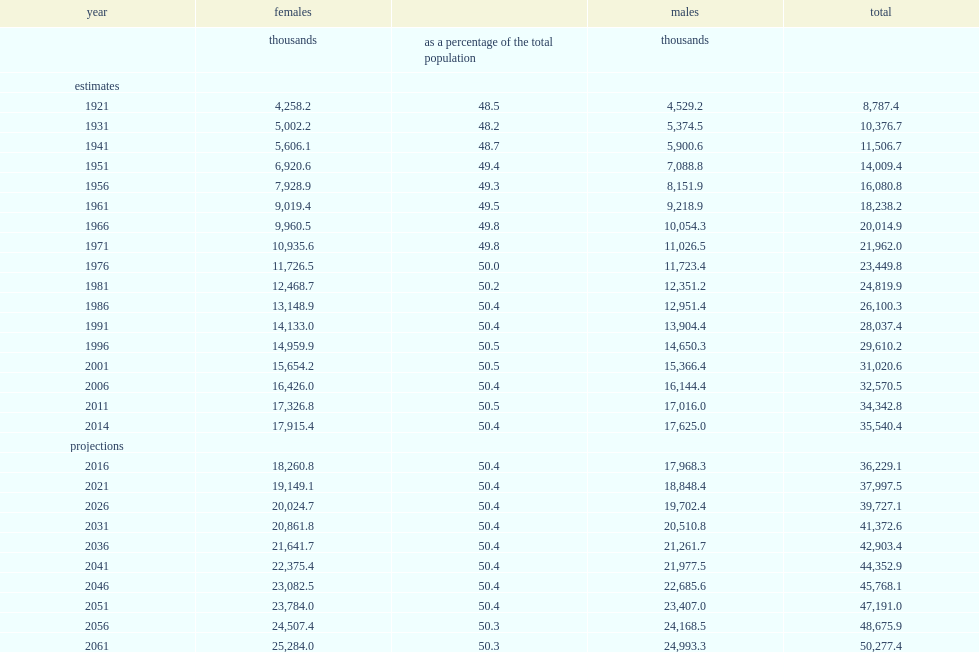Which gender was more comprised of canada's population as of july 1, 2014, females or males? Females. How many women and girls have grown in absolute numbers over the past century in 1921? 4258.2. Based on the medium-growth scenario of these projections, how many females could canada have by 2031? 20861.8. Based on the medium-growth scenario of these projections, how many females could canada have risen to by 2061? 25284.0. What was the percentage of women and girls accounted for of the total population on july 1, 2014? 50.4. What was the percentage of females represented of the population in 1921? 48.5. 